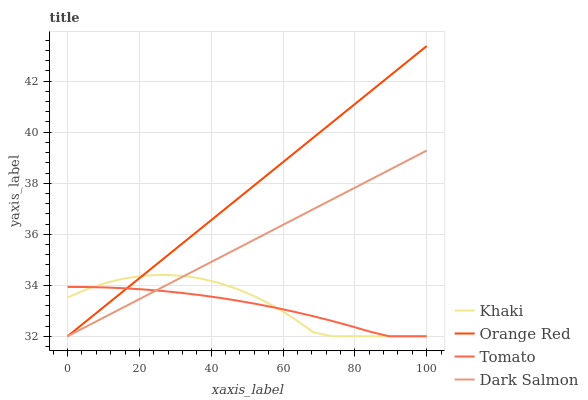Does Tomato have the minimum area under the curve?
Answer yes or no. Yes. Does Orange Red have the maximum area under the curve?
Answer yes or no. Yes. Does Khaki have the minimum area under the curve?
Answer yes or no. No. Does Khaki have the maximum area under the curve?
Answer yes or no. No. Is Orange Red the smoothest?
Answer yes or no. Yes. Is Khaki the roughest?
Answer yes or no. Yes. Is Khaki the smoothest?
Answer yes or no. No. Is Orange Red the roughest?
Answer yes or no. No. Does Tomato have the lowest value?
Answer yes or no. Yes. Does Orange Red have the highest value?
Answer yes or no. Yes. Does Khaki have the highest value?
Answer yes or no. No. Does Orange Red intersect Tomato?
Answer yes or no. Yes. Is Orange Red less than Tomato?
Answer yes or no. No. Is Orange Red greater than Tomato?
Answer yes or no. No. 